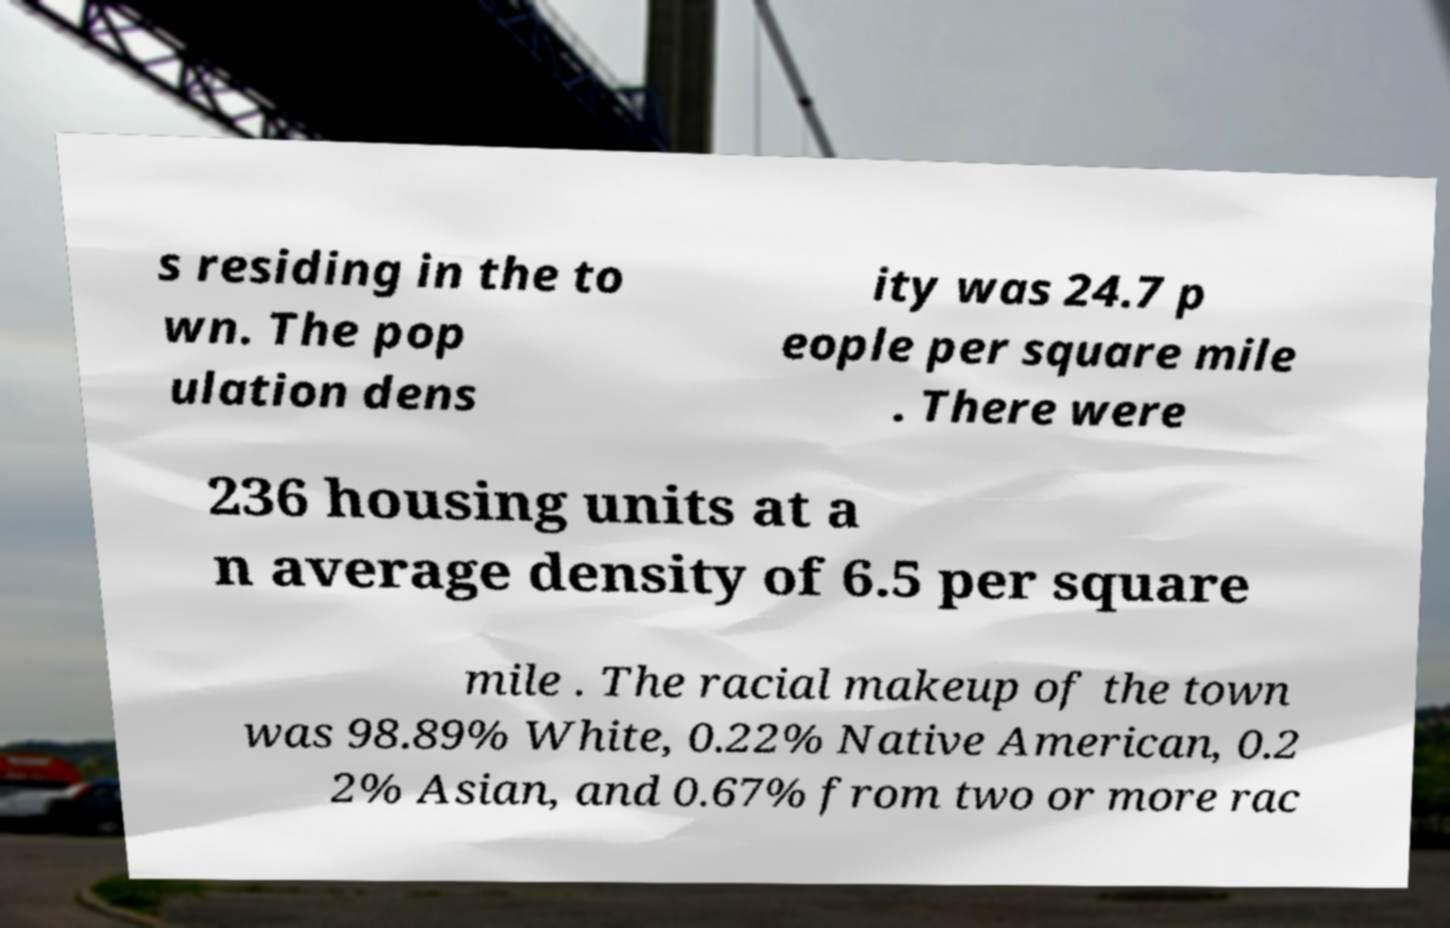Could you extract and type out the text from this image? s residing in the to wn. The pop ulation dens ity was 24.7 p eople per square mile . There were 236 housing units at a n average density of 6.5 per square mile . The racial makeup of the town was 98.89% White, 0.22% Native American, 0.2 2% Asian, and 0.67% from two or more rac 